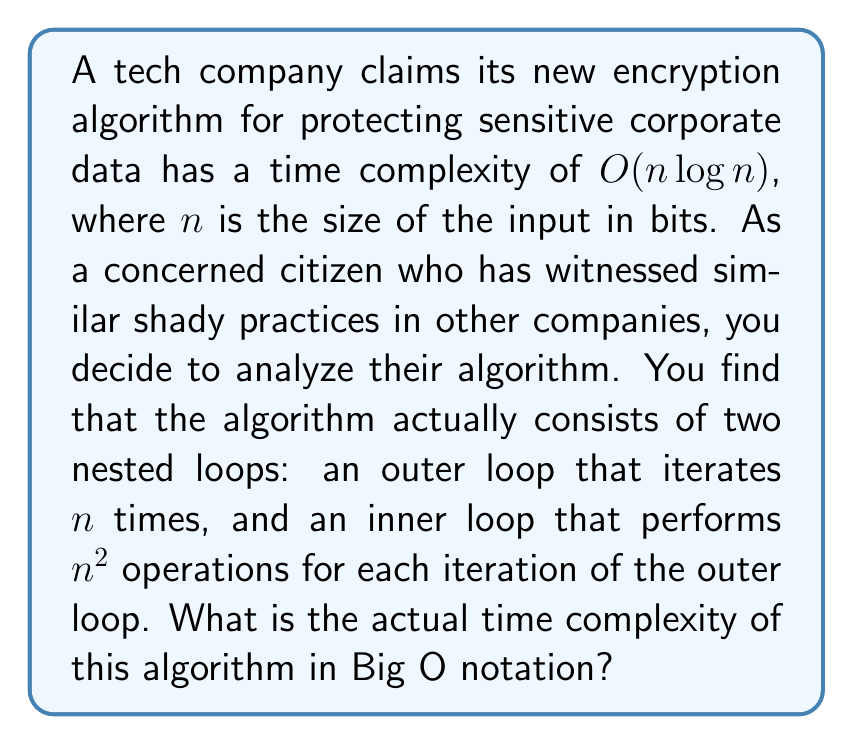What is the answer to this math problem? To determine the actual time complexity of the algorithm, we need to analyze the nested loop structure:

1. The outer loop iterates $n$ times.
2. For each iteration of the outer loop, the inner loop performs $n^2$ operations.

The total number of operations can be calculated as:

$$T(n) = n \cdot n^2 = n^3$$

This is because for each of the $n$ iterations of the outer loop, we perform $n^2$ operations in the inner loop.

To express this in Big O notation, we consider the highest-order term and drop any constants. In this case, the highest-order term is $n^3$.

Therefore, the actual time complexity of the algorithm is $O(n^3)$.

This analysis reveals that the algorithm is significantly less efficient than the company claimed. The difference between $O(n \log n)$ and $O(n^3)$ is substantial, especially for large inputs. This discrepancy could have serious implications for the performance and scalability of the encryption system, potentially compromising the protection of sensitive corporate data.
Answer: $O(n^3)$ 